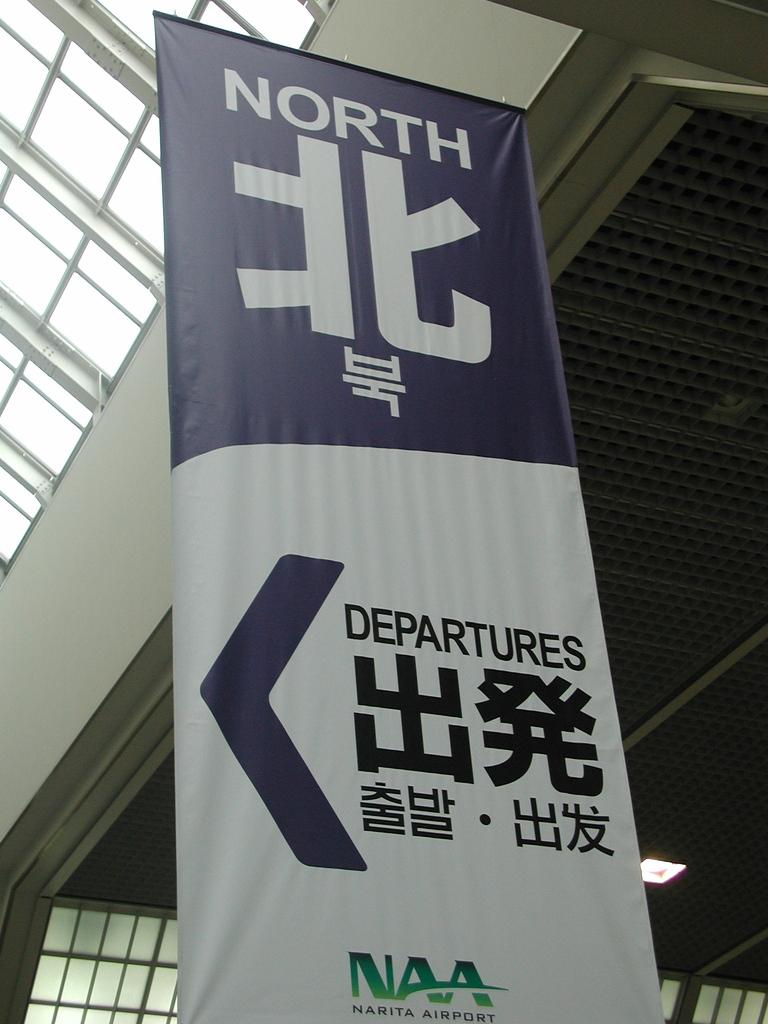What is hanging in the foreground of the image? There is a banner hanging in the foreground of the image. What architectural feature can be seen in the background of the image? There is a glass ceiling in the background of the image. What can be seen illuminated in the background of the image? There is a light visible in the background of the image. What is the cause of the celebration being depicted in the image? There is no indication of a celebration or any specific cause in the image. 